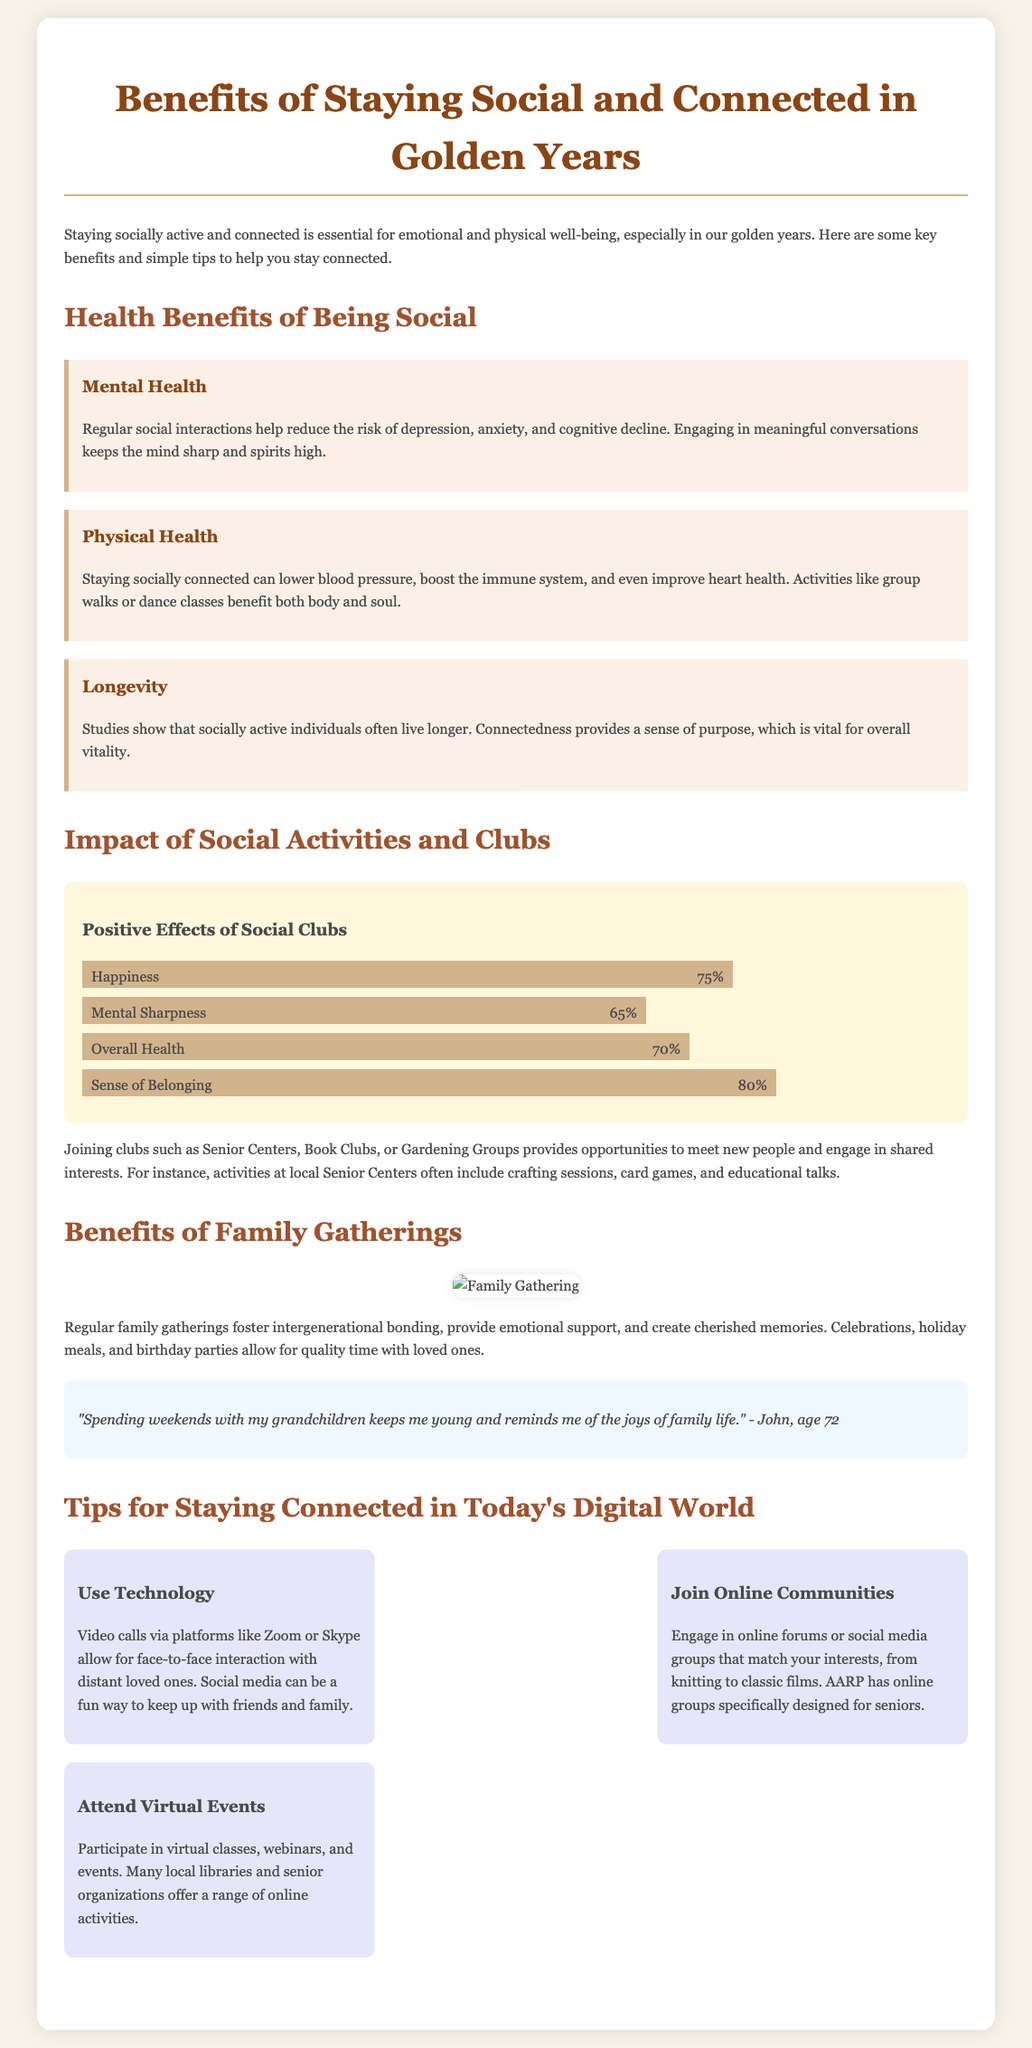What are some mental health benefits of being social? The document states that regular social interactions help reduce the risk of depression, anxiety, and cognitive decline.
Answer: Reduced depression, anxiety, and cognitive decline What is the percentage for the sense of belonging as a positive effect of social clubs? The infographic indicates that the sense of belonging has a positive effect with a value of 80%.
Answer: 80% Which types of activities are mentioned for Senior Centers? The document mentions crafting sessions, card games, and educational talks as activities at Senior Centers.
Answer: Crafting sessions, card games, educational talks What is one way to stay connected with distant loved ones? The document suggests using video calls via platforms like Zoom or Skype for staying connected.
Answer: Video calls How does staying socially connected impact physical health? It states that staying socially connected can lower blood pressure, boost the immune system, and even improve heart health.
Answer: Lower blood pressure, boost immune system, improve heart health What activity fosters intergenerational bonding according to the document? The document mentions that regular family gatherings foster intergenerational bonding.
Answer: Family gatherings Name one online community suggestion for seniors in the document. The document suggests engaging in online forums or social media groups that match your interests, from knitting to classic films.
Answer: Online forums or social media groups 